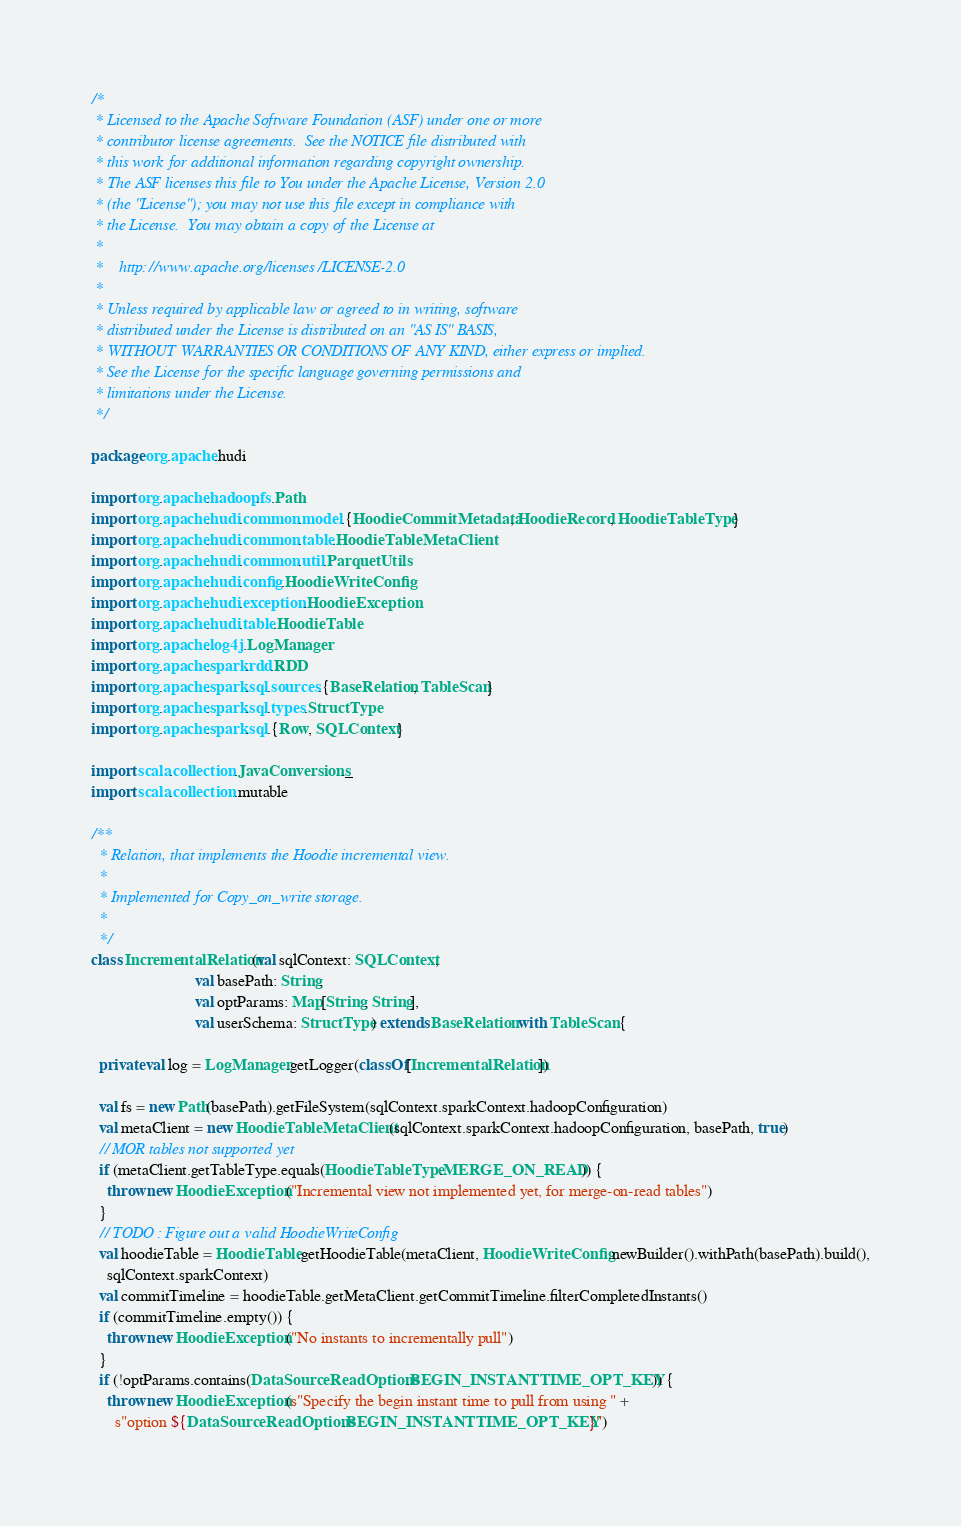<code> <loc_0><loc_0><loc_500><loc_500><_Scala_>/*
 * Licensed to the Apache Software Foundation (ASF) under one or more
 * contributor license agreements.  See the NOTICE file distributed with
 * this work for additional information regarding copyright ownership.
 * The ASF licenses this file to You under the Apache License, Version 2.0
 * (the "License"); you may not use this file except in compliance with
 * the License.  You may obtain a copy of the License at
 *
 *    http://www.apache.org/licenses/LICENSE-2.0
 *
 * Unless required by applicable law or agreed to in writing, software
 * distributed under the License is distributed on an "AS IS" BASIS,
 * WITHOUT WARRANTIES OR CONDITIONS OF ANY KIND, either express or implied.
 * See the License for the specific language governing permissions and
 * limitations under the License.
 */

package org.apache.hudi

import org.apache.hadoop.fs.Path
import org.apache.hudi.common.model.{HoodieCommitMetadata, HoodieRecord, HoodieTableType}
import org.apache.hudi.common.table.HoodieTableMetaClient
import org.apache.hudi.common.util.ParquetUtils
import org.apache.hudi.config.HoodieWriteConfig
import org.apache.hudi.exception.HoodieException
import org.apache.hudi.table.HoodieTable
import org.apache.log4j.LogManager
import org.apache.spark.rdd.RDD
import org.apache.spark.sql.sources.{BaseRelation, TableScan}
import org.apache.spark.sql.types.StructType
import org.apache.spark.sql.{Row, SQLContext}

import scala.collection.JavaConversions._
import scala.collection.mutable

/**
  * Relation, that implements the Hoodie incremental view.
  *
  * Implemented for Copy_on_write storage.
  *
  */
class IncrementalRelation(val sqlContext: SQLContext,
                          val basePath: String,
                          val optParams: Map[String, String],
                          val userSchema: StructType) extends BaseRelation with TableScan {

  private val log = LogManager.getLogger(classOf[IncrementalRelation])

  val fs = new Path(basePath).getFileSystem(sqlContext.sparkContext.hadoopConfiguration)
  val metaClient = new HoodieTableMetaClient(sqlContext.sparkContext.hadoopConfiguration, basePath, true)
  // MOR tables not supported yet
  if (metaClient.getTableType.equals(HoodieTableType.MERGE_ON_READ)) {
    throw new HoodieException("Incremental view not implemented yet, for merge-on-read tables")
  }
  // TODO : Figure out a valid HoodieWriteConfig
  val hoodieTable = HoodieTable.getHoodieTable(metaClient, HoodieWriteConfig.newBuilder().withPath(basePath).build(),
    sqlContext.sparkContext)
  val commitTimeline = hoodieTable.getMetaClient.getCommitTimeline.filterCompletedInstants()
  if (commitTimeline.empty()) {
    throw new HoodieException("No instants to incrementally pull")
  }
  if (!optParams.contains(DataSourceReadOptions.BEGIN_INSTANTTIME_OPT_KEY)) {
    throw new HoodieException(s"Specify the begin instant time to pull from using " +
      s"option ${DataSourceReadOptions.BEGIN_INSTANTTIME_OPT_KEY}")</code> 